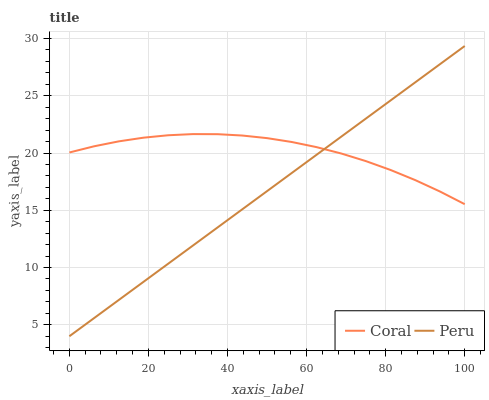Does Peru have the minimum area under the curve?
Answer yes or no. Yes. Does Coral have the maximum area under the curve?
Answer yes or no. Yes. Does Peru have the maximum area under the curve?
Answer yes or no. No. Is Peru the smoothest?
Answer yes or no. Yes. Is Coral the roughest?
Answer yes or no. Yes. Is Peru the roughest?
Answer yes or no. No. Does Peru have the highest value?
Answer yes or no. Yes. Does Peru intersect Coral?
Answer yes or no. Yes. Is Peru less than Coral?
Answer yes or no. No. Is Peru greater than Coral?
Answer yes or no. No. 